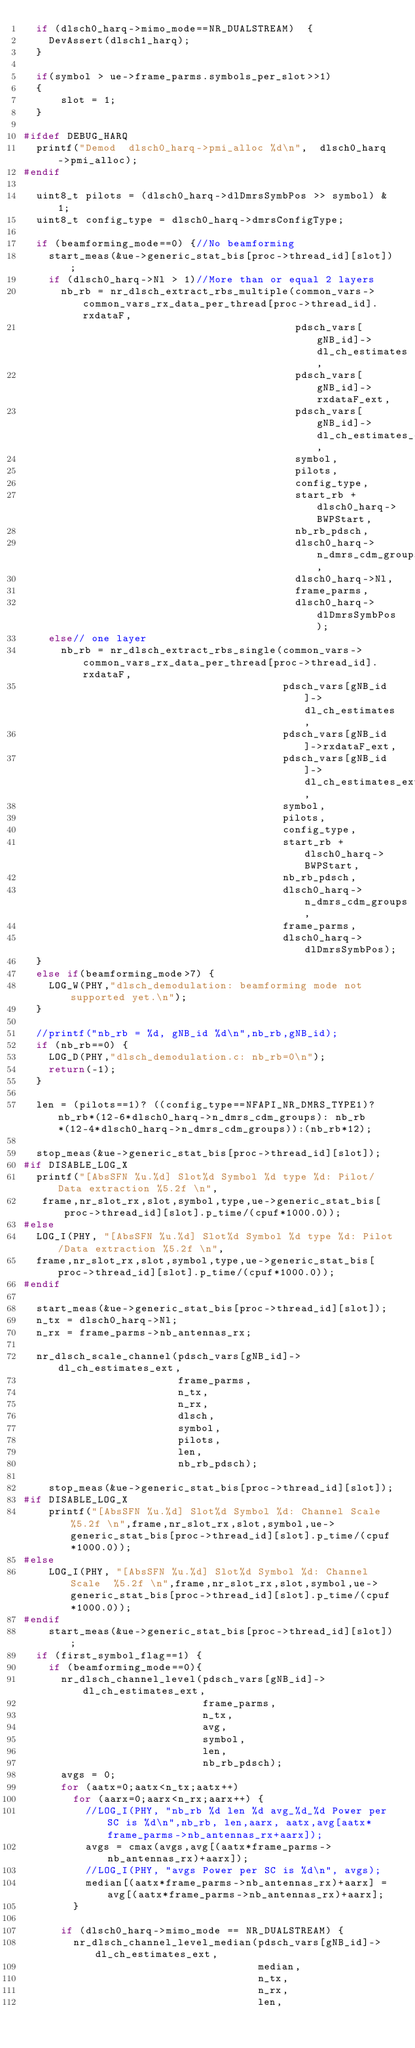Convert code to text. <code><loc_0><loc_0><loc_500><loc_500><_C_>  if (dlsch0_harq->mimo_mode==NR_DUALSTREAM)  {
    DevAssert(dlsch1_harq);
  }

  if(symbol > ue->frame_parms.symbols_per_slot>>1)
  {
      slot = 1;
  }

#ifdef DEBUG_HARQ
  printf("Demod  dlsch0_harq->pmi_alloc %d\n",  dlsch0_harq->pmi_alloc);
#endif

  uint8_t pilots = (dlsch0_harq->dlDmrsSymbPos >> symbol) & 1;
  uint8_t config_type = dlsch0_harq->dmrsConfigType;

  if (beamforming_mode==0) {//No beamforming
    start_meas(&ue->generic_stat_bis[proc->thread_id][slot]);
    if (dlsch0_harq->Nl > 1)//More than or equal 2 layers
      nb_rb = nr_dlsch_extract_rbs_multiple(common_vars->common_vars_rx_data_per_thread[proc->thread_id].rxdataF,
                                            pdsch_vars[gNB_id]->dl_ch_estimates,
                                            pdsch_vars[gNB_id]->rxdataF_ext,
                                            pdsch_vars[gNB_id]->dl_ch_estimates_ext,
                                            symbol,
                                            pilots,
                                            config_type,
                                            start_rb + dlsch0_harq->BWPStart,
                                            nb_rb_pdsch,
                                            dlsch0_harq->n_dmrs_cdm_groups,
                                            dlsch0_harq->Nl,
                                            frame_parms,
                                            dlsch0_harq->dlDmrsSymbPos);
    else// one layer
      nb_rb = nr_dlsch_extract_rbs_single(common_vars->common_vars_rx_data_per_thread[proc->thread_id].rxdataF,
                                          pdsch_vars[gNB_id]->dl_ch_estimates,
                                          pdsch_vars[gNB_id]->rxdataF_ext,
                                          pdsch_vars[gNB_id]->dl_ch_estimates_ext,
                                          symbol,
                                          pilots,
                                          config_type,
                                          start_rb + dlsch0_harq->BWPStart,
                                          nb_rb_pdsch,
                                          dlsch0_harq->n_dmrs_cdm_groups,
                                          frame_parms,
                                          dlsch0_harq->dlDmrsSymbPos);
  }
  else if(beamforming_mode>7) {
    LOG_W(PHY,"dlsch_demodulation: beamforming mode not supported yet.\n");
  }
  
  //printf("nb_rb = %d, gNB_id %d\n",nb_rb,gNB_id);
  if (nb_rb==0) {
    LOG_D(PHY,"dlsch_demodulation.c: nb_rb=0\n");
    return(-1);
  }

  len = (pilots==1)? ((config_type==NFAPI_NR_DMRS_TYPE1)?nb_rb*(12-6*dlsch0_harq->n_dmrs_cdm_groups): nb_rb*(12-4*dlsch0_harq->n_dmrs_cdm_groups)):(nb_rb*12);

  stop_meas(&ue->generic_stat_bis[proc->thread_id][slot]);
#if DISABLE_LOG_X
  printf("[AbsSFN %u.%d] Slot%d Symbol %d type %d: Pilot/Data extraction %5.2f \n",
	 frame,nr_slot_rx,slot,symbol,type,ue->generic_stat_bis[proc->thread_id][slot].p_time/(cpuf*1000.0));
#else
  LOG_I(PHY, "[AbsSFN %u.%d] Slot%d Symbol %d type %d: Pilot/Data extraction %5.2f \n",
	frame,nr_slot_rx,slot,symbol,type,ue->generic_stat_bis[proc->thread_id][slot].p_time/(cpuf*1000.0));
#endif
  
  start_meas(&ue->generic_stat_bis[proc->thread_id][slot]);
  n_tx = dlsch0_harq->Nl;
  n_rx = frame_parms->nb_antennas_rx;
  
  nr_dlsch_scale_channel(pdsch_vars[gNB_id]->dl_ch_estimates_ext,
                         frame_parms,
                         n_tx,
                         n_rx,
                         dlsch,
                         symbol,
                         pilots,
                         len,
                         nb_rb_pdsch);

    stop_meas(&ue->generic_stat_bis[proc->thread_id][slot]);
#if DISABLE_LOG_X
    printf("[AbsSFN %u.%d] Slot%d Symbol %d: Channel Scale %5.2f \n",frame,nr_slot_rx,slot,symbol,ue->generic_stat_bis[proc->thread_id][slot].p_time/(cpuf*1000.0));
#else
    LOG_I(PHY, "[AbsSFN %u.%d] Slot%d Symbol %d: Channel Scale  %5.2f \n",frame,nr_slot_rx,slot,symbol,ue->generic_stat_bis[proc->thread_id][slot].p_time/(cpuf*1000.0));
#endif
    start_meas(&ue->generic_stat_bis[proc->thread_id][slot]);
  if (first_symbol_flag==1) {
    if (beamforming_mode==0){
      nr_dlsch_channel_level(pdsch_vars[gNB_id]->dl_ch_estimates_ext,
                             frame_parms,
                             n_tx,
                             avg,
                             symbol,
                             len,
                             nb_rb_pdsch);
      avgs = 0;
      for (aatx=0;aatx<n_tx;aatx++)
        for (aarx=0;aarx<n_rx;aarx++) {
          //LOG_I(PHY, "nb_rb %d len %d avg_%d_%d Power per SC is %d\n",nb_rb, len,aarx, aatx,avg[aatx*frame_parms->nb_antennas_rx+aarx]);
          avgs = cmax(avgs,avg[(aatx*frame_parms->nb_antennas_rx)+aarx]);
          //LOG_I(PHY, "avgs Power per SC is %d\n", avgs);
          median[(aatx*frame_parms->nb_antennas_rx)+aarx] = avg[(aatx*frame_parms->nb_antennas_rx)+aarx];
        }

      if (dlsch0_harq->mimo_mode == NR_DUALSTREAM) {
        nr_dlsch_channel_level_median(pdsch_vars[gNB_id]->dl_ch_estimates_ext,
                                      median,
                                      n_tx,
                                      n_rx,
                                      len,</code> 